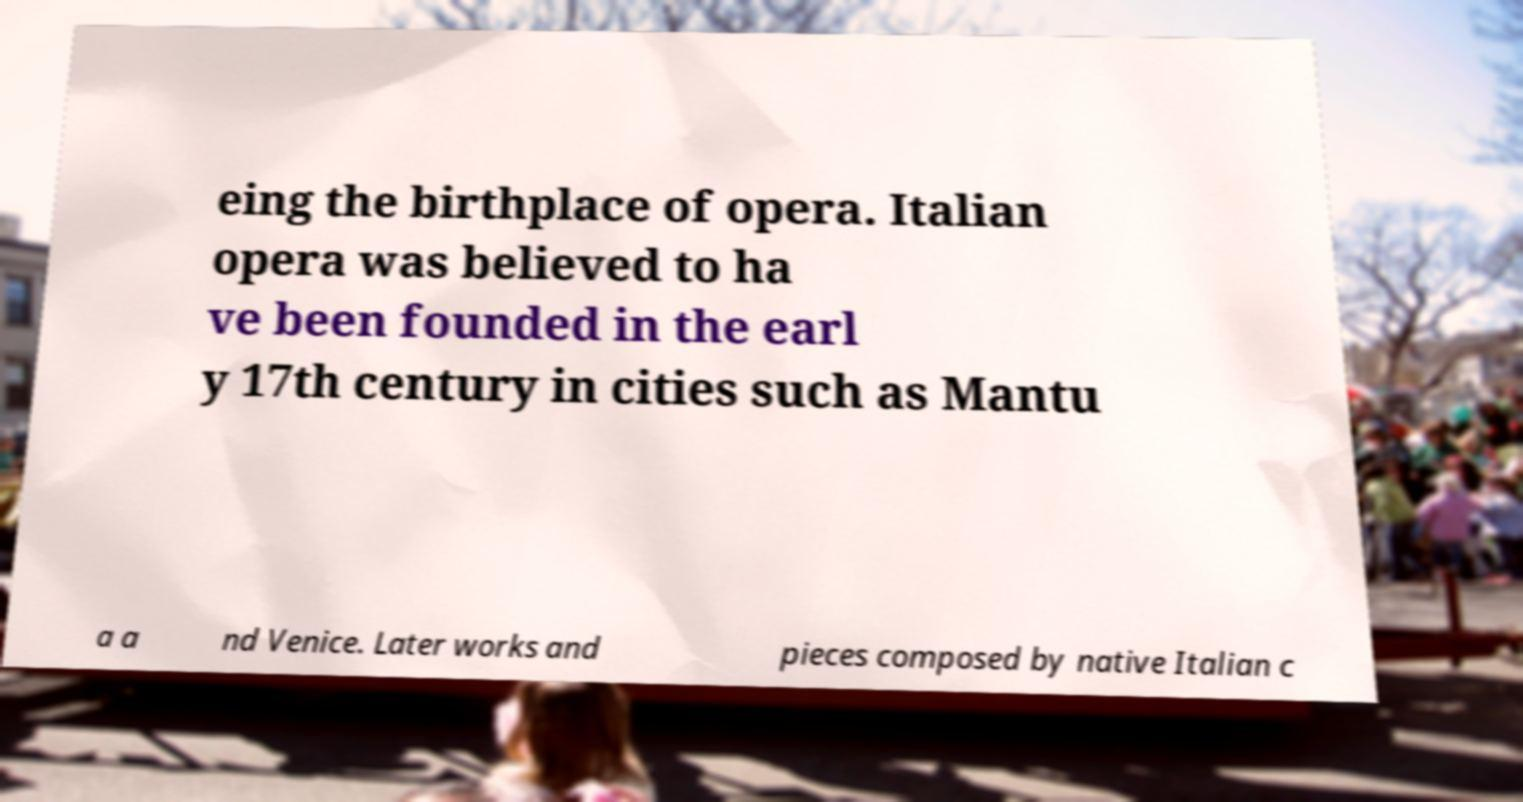Can you read and provide the text displayed in the image?This photo seems to have some interesting text. Can you extract and type it out for me? eing the birthplace of opera. Italian opera was believed to ha ve been founded in the earl y 17th century in cities such as Mantu a a nd Venice. Later works and pieces composed by native Italian c 